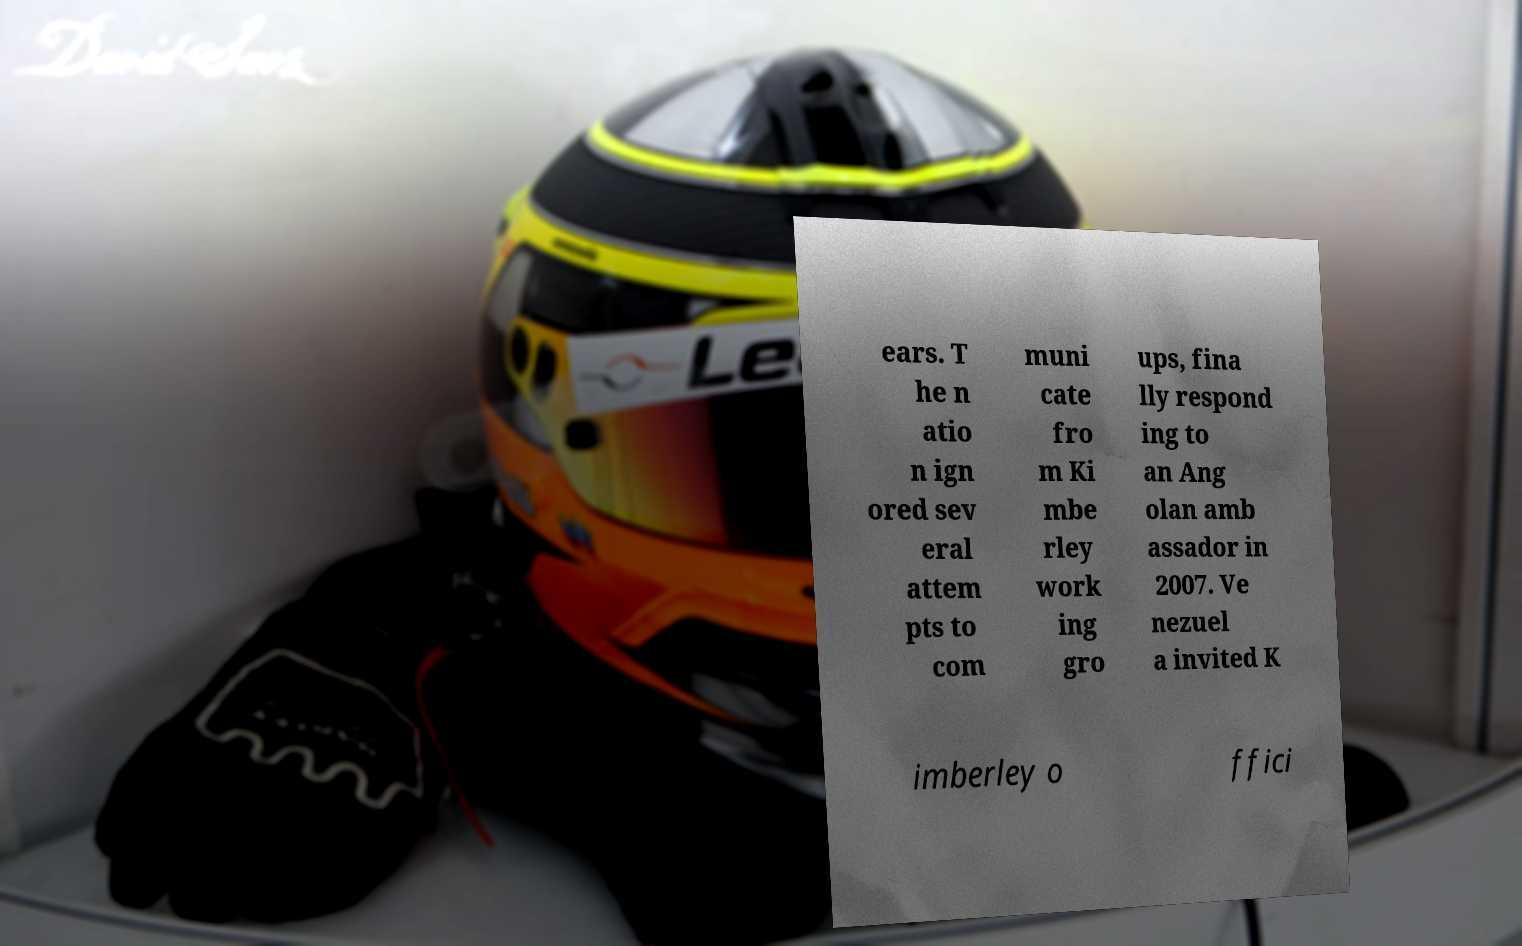I need the written content from this picture converted into text. Can you do that? ears. T he n atio n ign ored sev eral attem pts to com muni cate fro m Ki mbe rley work ing gro ups, fina lly respond ing to an Ang olan amb assador in 2007. Ve nezuel a invited K imberley o ffici 